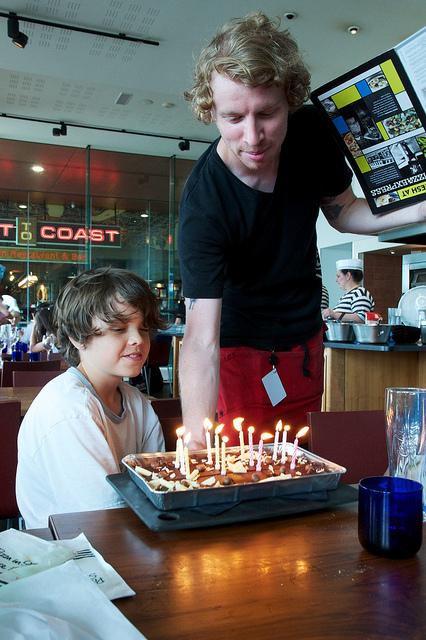What are they celebrating?
Give a very brief answer. Birthday. What time of year is it?
Write a very short answer. Summer. How many people are looking at the cake right now?
Quick response, please. 2. How many candles are there?
Write a very short answer. 12. Does this take place in someone's home?
Answer briefly. No. Where was this picture taken?
Short answer required. Restaurant. 